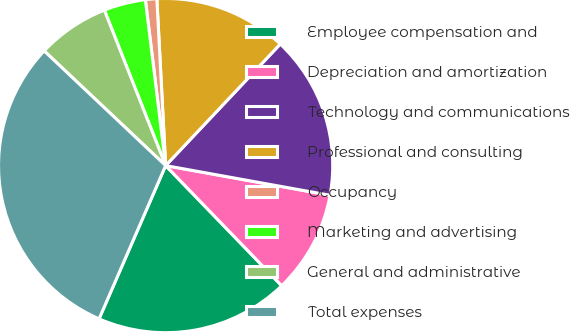Convert chart. <chart><loc_0><loc_0><loc_500><loc_500><pie_chart><fcel>Employee compensation and<fcel>Depreciation and amortization<fcel>Technology and communications<fcel>Professional and consulting<fcel>Occupancy<fcel>Marketing and advertising<fcel>General and administrative<fcel>Total expenses<nl><fcel>18.75%<fcel>9.93%<fcel>15.81%<fcel>12.87%<fcel>1.1%<fcel>4.04%<fcel>6.98%<fcel>30.52%<nl></chart> 